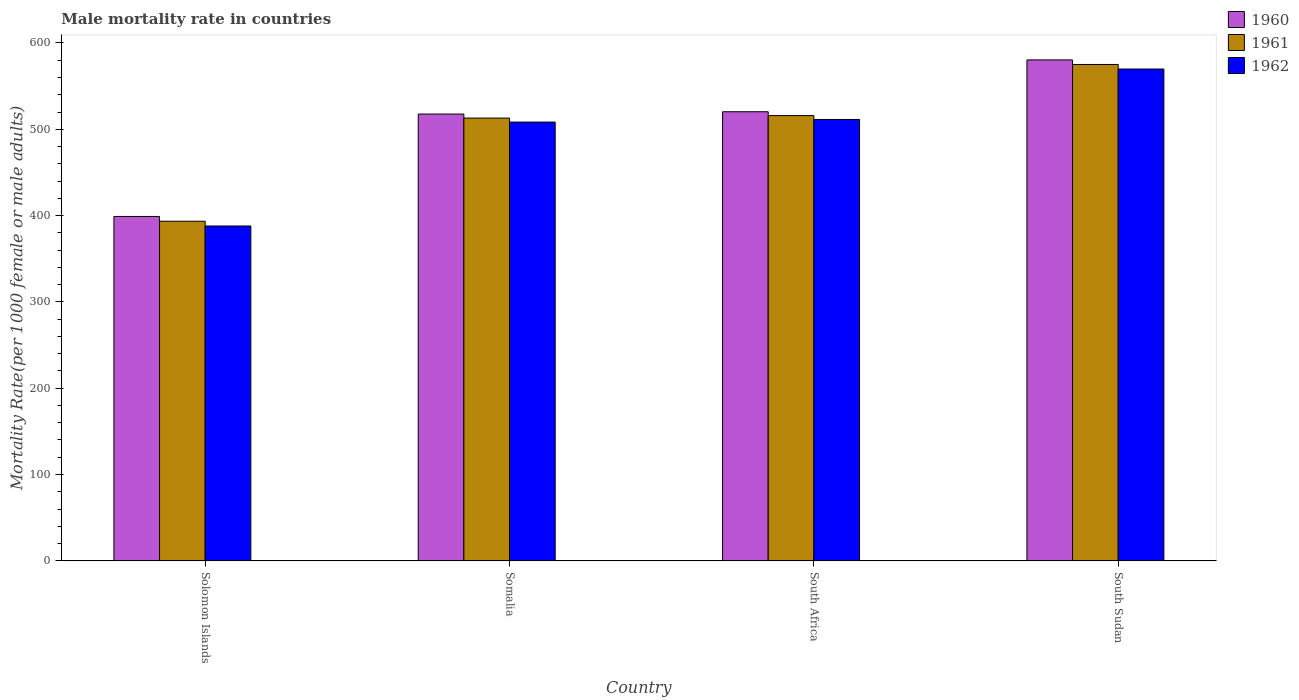How many groups of bars are there?
Your answer should be compact. 4. Are the number of bars per tick equal to the number of legend labels?
Keep it short and to the point. Yes. How many bars are there on the 4th tick from the left?
Keep it short and to the point. 3. How many bars are there on the 4th tick from the right?
Provide a succinct answer. 3. What is the label of the 2nd group of bars from the left?
Ensure brevity in your answer.  Somalia. In how many cases, is the number of bars for a given country not equal to the number of legend labels?
Your answer should be compact. 0. What is the male mortality rate in 1960 in Somalia?
Provide a short and direct response. 517.62. Across all countries, what is the maximum male mortality rate in 1960?
Your response must be concise. 580.35. Across all countries, what is the minimum male mortality rate in 1960?
Ensure brevity in your answer.  398.99. In which country was the male mortality rate in 1961 maximum?
Provide a short and direct response. South Sudan. In which country was the male mortality rate in 1961 minimum?
Offer a very short reply. Solomon Islands. What is the total male mortality rate in 1960 in the graph?
Offer a terse response. 2017.28. What is the difference between the male mortality rate in 1962 in South Africa and that in South Sudan?
Keep it short and to the point. -58.45. What is the difference between the male mortality rate in 1962 in South Sudan and the male mortality rate in 1961 in Solomon Islands?
Offer a terse response. 176.34. What is the average male mortality rate in 1960 per country?
Provide a short and direct response. 504.32. What is the difference between the male mortality rate of/in 1962 and male mortality rate of/in 1960 in Solomon Islands?
Offer a terse response. -11.04. In how many countries, is the male mortality rate in 1961 greater than 360?
Your answer should be compact. 4. What is the ratio of the male mortality rate in 1962 in Solomon Islands to that in South Sudan?
Make the answer very short. 0.68. Is the male mortality rate in 1960 in Solomon Islands less than that in Somalia?
Make the answer very short. Yes. What is the difference between the highest and the second highest male mortality rate in 1961?
Make the answer very short. -2.85. What is the difference between the highest and the lowest male mortality rate in 1962?
Give a very brief answer. 181.86. Is the sum of the male mortality rate in 1961 in Solomon Islands and Somalia greater than the maximum male mortality rate in 1960 across all countries?
Your answer should be compact. Yes. What does the 3rd bar from the left in South Sudan represents?
Give a very brief answer. 1962. What does the 1st bar from the right in South Sudan represents?
Your answer should be compact. 1962. Is it the case that in every country, the sum of the male mortality rate in 1960 and male mortality rate in 1962 is greater than the male mortality rate in 1961?
Keep it short and to the point. Yes. How many bars are there?
Provide a short and direct response. 12. How many countries are there in the graph?
Give a very brief answer. 4. What is the difference between two consecutive major ticks on the Y-axis?
Provide a succinct answer. 100. Are the values on the major ticks of Y-axis written in scientific E-notation?
Offer a very short reply. No. How are the legend labels stacked?
Give a very brief answer. Vertical. What is the title of the graph?
Make the answer very short. Male mortality rate in countries. Does "1962" appear as one of the legend labels in the graph?
Give a very brief answer. Yes. What is the label or title of the Y-axis?
Your answer should be very brief. Mortality Rate(per 1000 female or male adults). What is the Mortality Rate(per 1000 female or male adults) of 1960 in Solomon Islands?
Offer a very short reply. 398.99. What is the Mortality Rate(per 1000 female or male adults) of 1961 in Solomon Islands?
Offer a terse response. 393.47. What is the Mortality Rate(per 1000 female or male adults) in 1962 in Solomon Islands?
Provide a short and direct response. 387.95. What is the Mortality Rate(per 1000 female or male adults) of 1960 in Somalia?
Keep it short and to the point. 517.62. What is the Mortality Rate(per 1000 female or male adults) of 1961 in Somalia?
Provide a succinct answer. 512.99. What is the Mortality Rate(per 1000 female or male adults) in 1962 in Somalia?
Your answer should be compact. 508.35. What is the Mortality Rate(per 1000 female or male adults) in 1960 in South Africa?
Offer a very short reply. 520.32. What is the Mortality Rate(per 1000 female or male adults) in 1961 in South Africa?
Your answer should be compact. 515.84. What is the Mortality Rate(per 1000 female or male adults) in 1962 in South Africa?
Provide a succinct answer. 511.35. What is the Mortality Rate(per 1000 female or male adults) in 1960 in South Sudan?
Your answer should be compact. 580.35. What is the Mortality Rate(per 1000 female or male adults) in 1961 in South Sudan?
Ensure brevity in your answer.  575.08. What is the Mortality Rate(per 1000 female or male adults) of 1962 in South Sudan?
Offer a very short reply. 569.81. Across all countries, what is the maximum Mortality Rate(per 1000 female or male adults) in 1960?
Provide a short and direct response. 580.35. Across all countries, what is the maximum Mortality Rate(per 1000 female or male adults) in 1961?
Your answer should be very brief. 575.08. Across all countries, what is the maximum Mortality Rate(per 1000 female or male adults) in 1962?
Make the answer very short. 569.81. Across all countries, what is the minimum Mortality Rate(per 1000 female or male adults) of 1960?
Provide a short and direct response. 398.99. Across all countries, what is the minimum Mortality Rate(per 1000 female or male adults) of 1961?
Keep it short and to the point. 393.47. Across all countries, what is the minimum Mortality Rate(per 1000 female or male adults) of 1962?
Keep it short and to the point. 387.95. What is the total Mortality Rate(per 1000 female or male adults) in 1960 in the graph?
Your answer should be very brief. 2017.28. What is the total Mortality Rate(per 1000 female or male adults) in 1961 in the graph?
Offer a terse response. 1997.37. What is the total Mortality Rate(per 1000 female or male adults) in 1962 in the graph?
Make the answer very short. 1977.46. What is the difference between the Mortality Rate(per 1000 female or male adults) of 1960 in Solomon Islands and that in Somalia?
Offer a terse response. -118.64. What is the difference between the Mortality Rate(per 1000 female or male adults) of 1961 in Solomon Islands and that in Somalia?
Offer a terse response. -119.52. What is the difference between the Mortality Rate(per 1000 female or male adults) of 1962 in Solomon Islands and that in Somalia?
Provide a short and direct response. -120.41. What is the difference between the Mortality Rate(per 1000 female or male adults) in 1960 in Solomon Islands and that in South Africa?
Your answer should be very brief. -121.33. What is the difference between the Mortality Rate(per 1000 female or male adults) of 1961 in Solomon Islands and that in South Africa?
Provide a short and direct response. -122.37. What is the difference between the Mortality Rate(per 1000 female or male adults) in 1962 in Solomon Islands and that in South Africa?
Your answer should be very brief. -123.41. What is the difference between the Mortality Rate(per 1000 female or male adults) of 1960 in Solomon Islands and that in South Sudan?
Make the answer very short. -181.36. What is the difference between the Mortality Rate(per 1000 female or male adults) in 1961 in Solomon Islands and that in South Sudan?
Provide a short and direct response. -181.61. What is the difference between the Mortality Rate(per 1000 female or male adults) of 1962 in Solomon Islands and that in South Sudan?
Offer a very short reply. -181.86. What is the difference between the Mortality Rate(per 1000 female or male adults) of 1960 in Somalia and that in South Africa?
Give a very brief answer. -2.69. What is the difference between the Mortality Rate(per 1000 female or male adults) of 1961 in Somalia and that in South Africa?
Give a very brief answer. -2.85. What is the difference between the Mortality Rate(per 1000 female or male adults) in 1962 in Somalia and that in South Africa?
Your answer should be compact. -3. What is the difference between the Mortality Rate(per 1000 female or male adults) in 1960 in Somalia and that in South Sudan?
Keep it short and to the point. -62.73. What is the difference between the Mortality Rate(per 1000 female or male adults) of 1961 in Somalia and that in South Sudan?
Make the answer very short. -62.09. What is the difference between the Mortality Rate(per 1000 female or male adults) of 1962 in Somalia and that in South Sudan?
Ensure brevity in your answer.  -61.46. What is the difference between the Mortality Rate(per 1000 female or male adults) in 1960 in South Africa and that in South Sudan?
Provide a short and direct response. -60.03. What is the difference between the Mortality Rate(per 1000 female or male adults) in 1961 in South Africa and that in South Sudan?
Your answer should be compact. -59.24. What is the difference between the Mortality Rate(per 1000 female or male adults) of 1962 in South Africa and that in South Sudan?
Offer a terse response. -58.45. What is the difference between the Mortality Rate(per 1000 female or male adults) of 1960 in Solomon Islands and the Mortality Rate(per 1000 female or male adults) of 1961 in Somalia?
Give a very brief answer. -114. What is the difference between the Mortality Rate(per 1000 female or male adults) of 1960 in Solomon Islands and the Mortality Rate(per 1000 female or male adults) of 1962 in Somalia?
Your answer should be very brief. -109.36. What is the difference between the Mortality Rate(per 1000 female or male adults) in 1961 in Solomon Islands and the Mortality Rate(per 1000 female or male adults) in 1962 in Somalia?
Your answer should be very brief. -114.88. What is the difference between the Mortality Rate(per 1000 female or male adults) in 1960 in Solomon Islands and the Mortality Rate(per 1000 female or male adults) in 1961 in South Africa?
Make the answer very short. -116.85. What is the difference between the Mortality Rate(per 1000 female or male adults) in 1960 in Solomon Islands and the Mortality Rate(per 1000 female or male adults) in 1962 in South Africa?
Your answer should be very brief. -112.36. What is the difference between the Mortality Rate(per 1000 female or male adults) of 1961 in Solomon Islands and the Mortality Rate(per 1000 female or male adults) of 1962 in South Africa?
Provide a short and direct response. -117.89. What is the difference between the Mortality Rate(per 1000 female or male adults) of 1960 in Solomon Islands and the Mortality Rate(per 1000 female or male adults) of 1961 in South Sudan?
Your answer should be very brief. -176.09. What is the difference between the Mortality Rate(per 1000 female or male adults) in 1960 in Solomon Islands and the Mortality Rate(per 1000 female or male adults) in 1962 in South Sudan?
Ensure brevity in your answer.  -170.82. What is the difference between the Mortality Rate(per 1000 female or male adults) in 1961 in Solomon Islands and the Mortality Rate(per 1000 female or male adults) in 1962 in South Sudan?
Provide a short and direct response. -176.34. What is the difference between the Mortality Rate(per 1000 female or male adults) of 1960 in Somalia and the Mortality Rate(per 1000 female or male adults) of 1961 in South Africa?
Give a very brief answer. 1.79. What is the difference between the Mortality Rate(per 1000 female or male adults) in 1960 in Somalia and the Mortality Rate(per 1000 female or male adults) in 1962 in South Africa?
Give a very brief answer. 6.27. What is the difference between the Mortality Rate(per 1000 female or male adults) in 1961 in Somalia and the Mortality Rate(per 1000 female or male adults) in 1962 in South Africa?
Ensure brevity in your answer.  1.63. What is the difference between the Mortality Rate(per 1000 female or male adults) in 1960 in Somalia and the Mortality Rate(per 1000 female or male adults) in 1961 in South Sudan?
Give a very brief answer. -57.46. What is the difference between the Mortality Rate(per 1000 female or male adults) of 1960 in Somalia and the Mortality Rate(per 1000 female or male adults) of 1962 in South Sudan?
Make the answer very short. -52.19. What is the difference between the Mortality Rate(per 1000 female or male adults) in 1961 in Somalia and the Mortality Rate(per 1000 female or male adults) in 1962 in South Sudan?
Make the answer very short. -56.82. What is the difference between the Mortality Rate(per 1000 female or male adults) of 1960 in South Africa and the Mortality Rate(per 1000 female or male adults) of 1961 in South Sudan?
Provide a succinct answer. -54.76. What is the difference between the Mortality Rate(per 1000 female or male adults) in 1960 in South Africa and the Mortality Rate(per 1000 female or male adults) in 1962 in South Sudan?
Keep it short and to the point. -49.49. What is the difference between the Mortality Rate(per 1000 female or male adults) of 1961 in South Africa and the Mortality Rate(per 1000 female or male adults) of 1962 in South Sudan?
Ensure brevity in your answer.  -53.97. What is the average Mortality Rate(per 1000 female or male adults) of 1960 per country?
Your response must be concise. 504.32. What is the average Mortality Rate(per 1000 female or male adults) in 1961 per country?
Offer a terse response. 499.34. What is the average Mortality Rate(per 1000 female or male adults) of 1962 per country?
Offer a very short reply. 494.37. What is the difference between the Mortality Rate(per 1000 female or male adults) in 1960 and Mortality Rate(per 1000 female or male adults) in 1961 in Solomon Islands?
Give a very brief answer. 5.52. What is the difference between the Mortality Rate(per 1000 female or male adults) of 1960 and Mortality Rate(per 1000 female or male adults) of 1962 in Solomon Islands?
Ensure brevity in your answer.  11.04. What is the difference between the Mortality Rate(per 1000 female or male adults) in 1961 and Mortality Rate(per 1000 female or male adults) in 1962 in Solomon Islands?
Provide a succinct answer. 5.52. What is the difference between the Mortality Rate(per 1000 female or male adults) in 1960 and Mortality Rate(per 1000 female or male adults) in 1961 in Somalia?
Provide a short and direct response. 4.64. What is the difference between the Mortality Rate(per 1000 female or male adults) in 1960 and Mortality Rate(per 1000 female or male adults) in 1962 in Somalia?
Provide a succinct answer. 9.27. What is the difference between the Mortality Rate(per 1000 female or male adults) of 1961 and Mortality Rate(per 1000 female or male adults) of 1962 in Somalia?
Give a very brief answer. 4.64. What is the difference between the Mortality Rate(per 1000 female or male adults) in 1960 and Mortality Rate(per 1000 female or male adults) in 1961 in South Africa?
Offer a very short reply. 4.48. What is the difference between the Mortality Rate(per 1000 female or male adults) of 1960 and Mortality Rate(per 1000 female or male adults) of 1962 in South Africa?
Your response must be concise. 8.96. What is the difference between the Mortality Rate(per 1000 female or male adults) in 1961 and Mortality Rate(per 1000 female or male adults) in 1962 in South Africa?
Give a very brief answer. 4.48. What is the difference between the Mortality Rate(per 1000 female or male adults) in 1960 and Mortality Rate(per 1000 female or male adults) in 1961 in South Sudan?
Offer a very short reply. 5.27. What is the difference between the Mortality Rate(per 1000 female or male adults) of 1960 and Mortality Rate(per 1000 female or male adults) of 1962 in South Sudan?
Provide a succinct answer. 10.54. What is the difference between the Mortality Rate(per 1000 female or male adults) in 1961 and Mortality Rate(per 1000 female or male adults) in 1962 in South Sudan?
Ensure brevity in your answer.  5.27. What is the ratio of the Mortality Rate(per 1000 female or male adults) in 1960 in Solomon Islands to that in Somalia?
Provide a short and direct response. 0.77. What is the ratio of the Mortality Rate(per 1000 female or male adults) of 1961 in Solomon Islands to that in Somalia?
Keep it short and to the point. 0.77. What is the ratio of the Mortality Rate(per 1000 female or male adults) of 1962 in Solomon Islands to that in Somalia?
Offer a terse response. 0.76. What is the ratio of the Mortality Rate(per 1000 female or male adults) of 1960 in Solomon Islands to that in South Africa?
Provide a short and direct response. 0.77. What is the ratio of the Mortality Rate(per 1000 female or male adults) in 1961 in Solomon Islands to that in South Africa?
Your answer should be very brief. 0.76. What is the ratio of the Mortality Rate(per 1000 female or male adults) of 1962 in Solomon Islands to that in South Africa?
Your answer should be compact. 0.76. What is the ratio of the Mortality Rate(per 1000 female or male adults) in 1960 in Solomon Islands to that in South Sudan?
Give a very brief answer. 0.69. What is the ratio of the Mortality Rate(per 1000 female or male adults) of 1961 in Solomon Islands to that in South Sudan?
Provide a succinct answer. 0.68. What is the ratio of the Mortality Rate(per 1000 female or male adults) in 1962 in Solomon Islands to that in South Sudan?
Offer a terse response. 0.68. What is the ratio of the Mortality Rate(per 1000 female or male adults) of 1961 in Somalia to that in South Africa?
Give a very brief answer. 0.99. What is the ratio of the Mortality Rate(per 1000 female or male adults) of 1962 in Somalia to that in South Africa?
Your answer should be compact. 0.99. What is the ratio of the Mortality Rate(per 1000 female or male adults) in 1960 in Somalia to that in South Sudan?
Your answer should be very brief. 0.89. What is the ratio of the Mortality Rate(per 1000 female or male adults) of 1961 in Somalia to that in South Sudan?
Provide a short and direct response. 0.89. What is the ratio of the Mortality Rate(per 1000 female or male adults) in 1962 in Somalia to that in South Sudan?
Offer a terse response. 0.89. What is the ratio of the Mortality Rate(per 1000 female or male adults) in 1960 in South Africa to that in South Sudan?
Offer a terse response. 0.9. What is the ratio of the Mortality Rate(per 1000 female or male adults) of 1961 in South Africa to that in South Sudan?
Give a very brief answer. 0.9. What is the ratio of the Mortality Rate(per 1000 female or male adults) of 1962 in South Africa to that in South Sudan?
Make the answer very short. 0.9. What is the difference between the highest and the second highest Mortality Rate(per 1000 female or male adults) in 1960?
Offer a very short reply. 60.03. What is the difference between the highest and the second highest Mortality Rate(per 1000 female or male adults) in 1961?
Make the answer very short. 59.24. What is the difference between the highest and the second highest Mortality Rate(per 1000 female or male adults) of 1962?
Provide a short and direct response. 58.45. What is the difference between the highest and the lowest Mortality Rate(per 1000 female or male adults) of 1960?
Offer a very short reply. 181.36. What is the difference between the highest and the lowest Mortality Rate(per 1000 female or male adults) in 1961?
Provide a succinct answer. 181.61. What is the difference between the highest and the lowest Mortality Rate(per 1000 female or male adults) in 1962?
Ensure brevity in your answer.  181.86. 